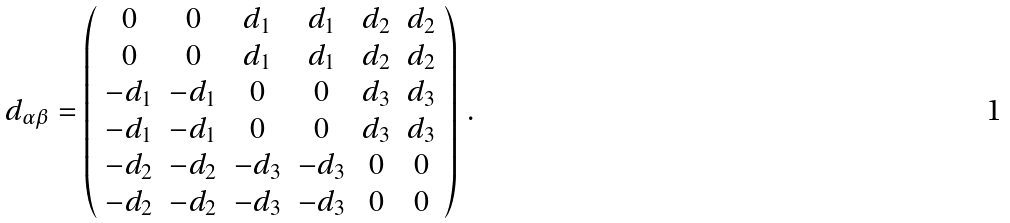Convert formula to latex. <formula><loc_0><loc_0><loc_500><loc_500>d _ { \alpha \beta } = \left ( \begin{array} { c c c c c c } 0 & 0 & d _ { 1 } & d _ { 1 } & d _ { 2 } & d _ { 2 } \\ 0 & 0 & d _ { 1 } & d _ { 1 } & d _ { 2 } & d _ { 2 } \\ - d _ { 1 } & - d _ { 1 } & 0 & 0 & d _ { 3 } & d _ { 3 } \\ - d _ { 1 } & - d _ { 1 } & 0 & 0 & d _ { 3 } & d _ { 3 } \\ - d _ { 2 } & - d _ { 2 } & - d _ { 3 } & - d _ { 3 } & 0 & 0 \\ - d _ { 2 } & - d _ { 2 } & - d _ { 3 } & - d _ { 3 } & 0 & 0 \end{array} \right ) \, .</formula> 